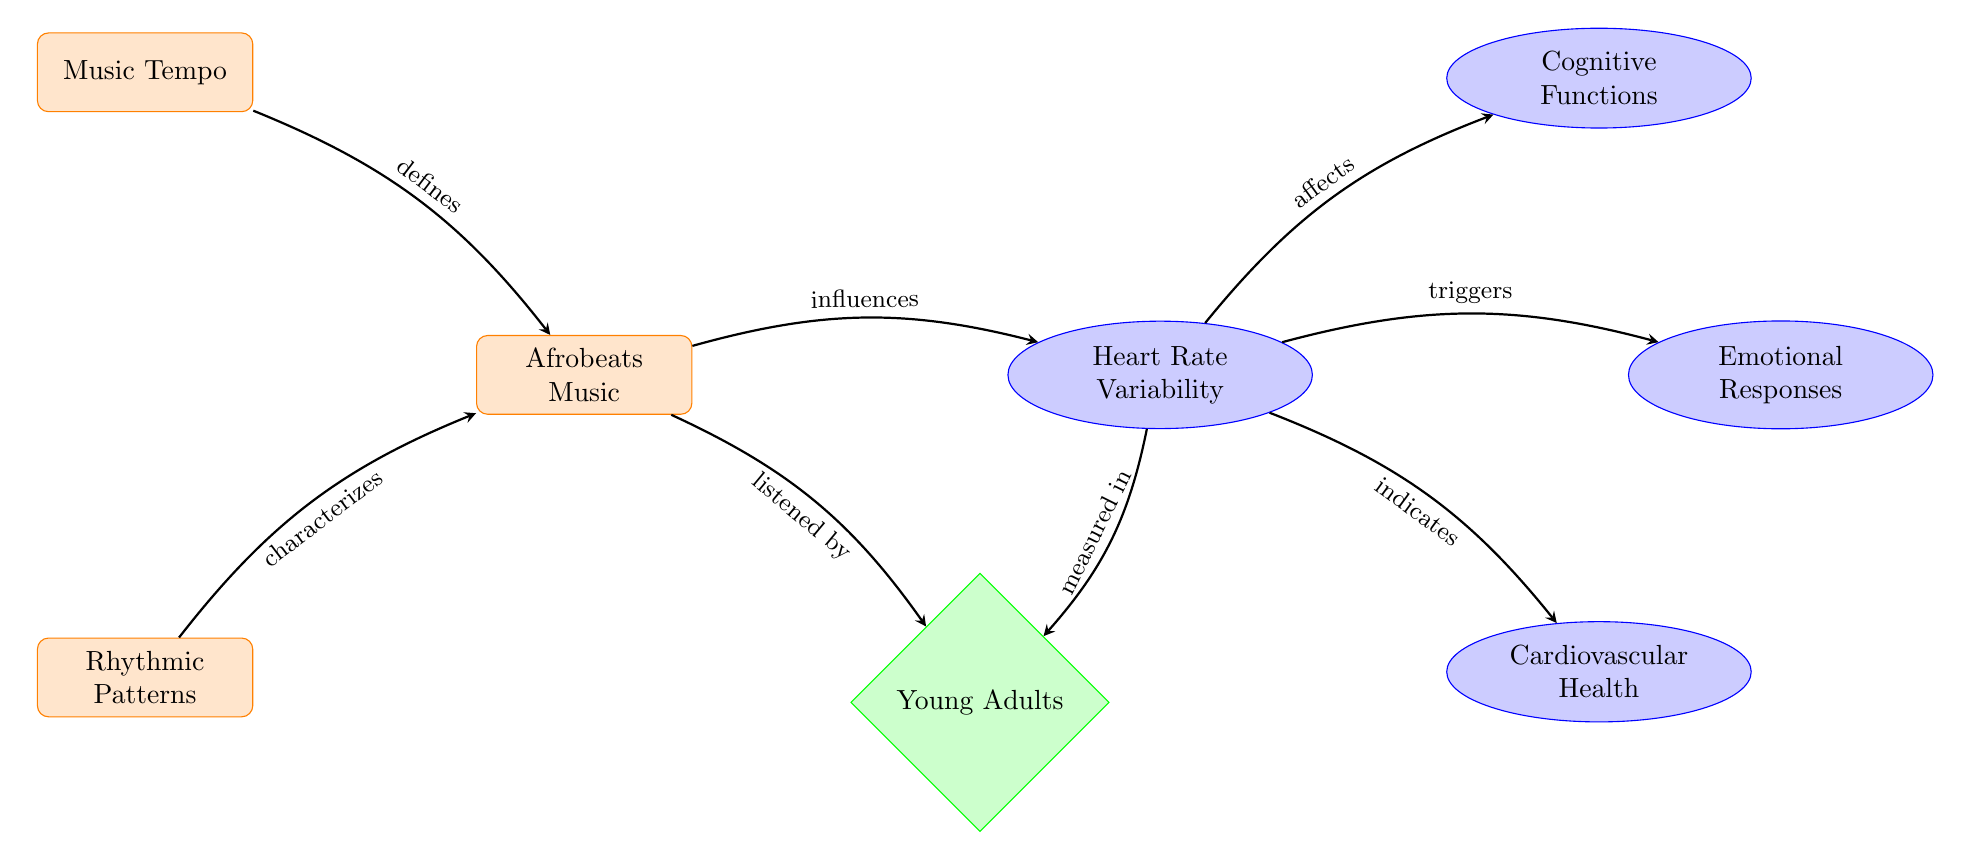What is the primary type of music represented in the diagram? The diagram starts with the node labeled "Afrobeats Music," indicating that this is the central focus of the diagram.
Answer: Afrobeats Music How many physiological impacts are indicated in the diagram? The diagram shows three physiological impacts linked to Heart Rate Variability: "Cognitive Functions," "Emotional Responses," and "Cardiovascular Health." This counts to three distinct impacts.
Answer: 3 What demographic is primarily affected according to the diagram? The diagram highlights the node "Young Adults," suggesting that they are the demographic being discussed in relation to Afrobeats and Heart Rate Variability.
Answer: Young Adults What influences Heart Rate Variability according to the diagram? The arrow from "Afrobeats Music" directly points to "Heart Rate Variability," indicating that Afrobeats influences this physiological measure.
Answer: Afrobeats Music What role does "Music Tempo" play in the context of Afrobeats according to the diagram? The diagram shows that "Music Tempo" defines "Afrobeats Music," implying that the tempo is a characteristic component of the music genre.
Answer: defines What physiological aspect is indicated to be measured in relation to "Young Adults"? The arrow from "Heart Rate Variability" points to "Young Adults," indicating that Heart Rate Variability is specifically measured in this demographic group.
Answer: Heart Rate Variability How does Heart Rate Variability affect cognitive functions? The diagram specifies that "Heart Rate Variability" affects "Cognitive Functions," demonstrating a direct link between the two concepts.
Answer: affects What does "Heart Rate Variability" trigger in the context of the diagram? An arrow from "Heart Rate Variability" points to "Emotional Responses," indicating that it triggers these responses.
Answer: Emotional Responses Which two elements characterize Afrobeats according to the diagram? The diagram shows that "Rhythmic Patterns" and "Music Tempo" both characterize "Afrobeats Music," highlighting key elements of the genre.
Answer: Rhythmic Patterns and Music Tempo 